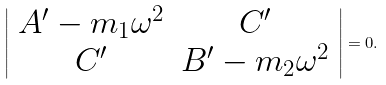<formula> <loc_0><loc_0><loc_500><loc_500>\left | \begin{array} { c c } A ^ { \prime } - m _ { 1 } \omega ^ { 2 } & C ^ { \prime } \\ C ^ { \prime } & B ^ { \prime } - m _ { 2 } \omega ^ { 2 } \end{array} \right | = 0 .</formula> 